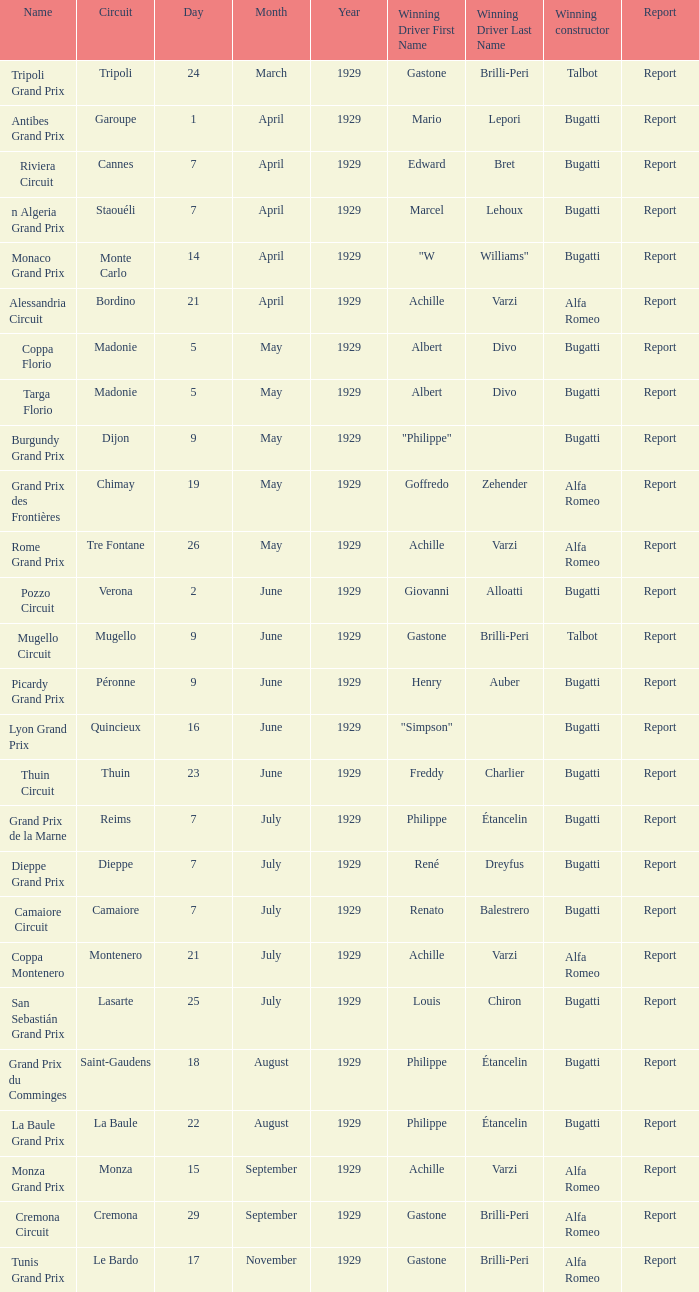What Winning driver has a Winning constructor of talbot? Gastone Brilli-Peri, Gastone Brilli-Peri. 